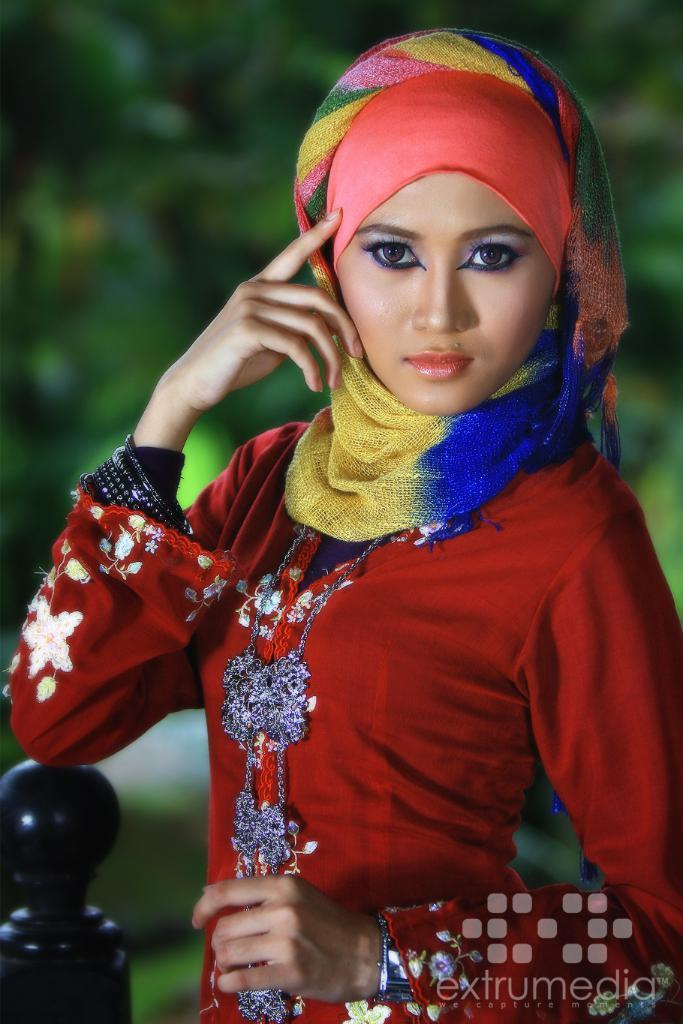What is the woman wearing around her neck in the image? The woman is wearing a scarf in the image. What color is the dress the woman is wearing? The woman is wearing a red dress in the image. Can you describe the background of the image? The background of the image is blurred. Is there any additional information or marking on the image? Yes, there is a watermark at the bottom of the image. What type of pain is the woman experiencing in the image? There is no indication of pain in the image; the woman appears to be wearing a scarf and a red dress. What punishment is the woman receiving in the image? There is no indication of punishment in the image; the woman is simply wearing a scarf and a red dress. 